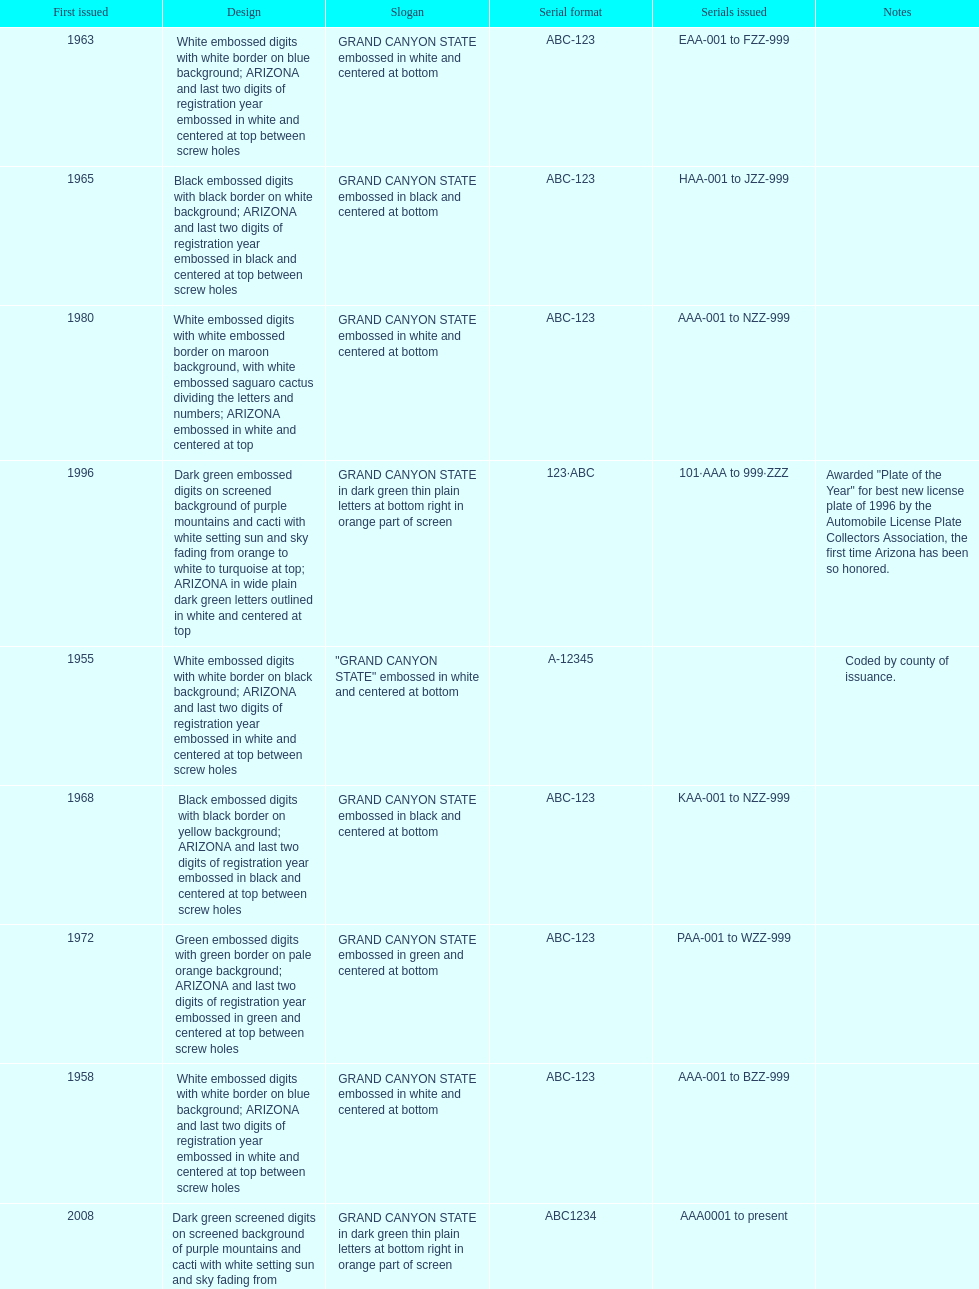Could you help me parse every detail presented in this table? {'header': ['First issued', 'Design', 'Slogan', 'Serial format', 'Serials issued', 'Notes'], 'rows': [['1963', 'White embossed digits with white border on blue background; ARIZONA and last two digits of registration year embossed in white and centered at top between screw holes', 'GRAND CANYON STATE embossed in white and centered at bottom', 'ABC-123', 'EAA-001 to FZZ-999', ''], ['1965', 'Black embossed digits with black border on white background; ARIZONA and last two digits of registration year embossed in black and centered at top between screw holes', 'GRAND CANYON STATE embossed in black and centered at bottom', 'ABC-123', 'HAA-001 to JZZ-999', ''], ['1980', 'White embossed digits with white embossed border on maroon background, with white embossed saguaro cactus dividing the letters and numbers; ARIZONA embossed in white and centered at top', 'GRAND CANYON STATE embossed in white and centered at bottom', 'ABC-123', 'AAA-001 to NZZ-999', ''], ['1996', 'Dark green embossed digits on screened background of purple mountains and cacti with white setting sun and sky fading from orange to white to turquoise at top; ARIZONA in wide plain dark green letters outlined in white and centered at top', 'GRAND CANYON STATE in dark green thin plain letters at bottom right in orange part of screen', '123·ABC', '101·AAA to 999·ZZZ', 'Awarded "Plate of the Year" for best new license plate of 1996 by the Automobile License Plate Collectors Association, the first time Arizona has been so honored.'], ['1955', 'White embossed digits with white border on black background; ARIZONA and last two digits of registration year embossed in white and centered at top between screw holes', '"GRAND CANYON STATE" embossed in white and centered at bottom', 'A-12345', '', 'Coded by county of issuance.'], ['1968', 'Black embossed digits with black border on yellow background; ARIZONA and last two digits of registration year embossed in black and centered at top between screw holes', 'GRAND CANYON STATE embossed in black and centered at bottom', 'ABC-123', 'KAA-001 to NZZ-999', ''], ['1972', 'Green embossed digits with green border on pale orange background; ARIZONA and last two digits of registration year embossed in green and centered at top between screw holes', 'GRAND CANYON STATE embossed in green and centered at bottom', 'ABC-123', 'PAA-001 to WZZ-999', ''], ['1958', 'White embossed digits with white border on blue background; ARIZONA and last two digits of registration year embossed in white and centered at top between screw holes', 'GRAND CANYON STATE embossed in white and centered at bottom', 'ABC-123', 'AAA-001 to BZZ-999', ''], ['2008', 'Dark green screened digits on screened background of purple mountains and cacti with white setting sun and sky fading from orange to white to turquoise at top; ARIZONA in wide plain dark green letters outlined in white and centered at top; security stripe through center of plate', 'GRAND CANYON STATE in dark green thin plain letters at bottom right in orange part of screen', 'ABC1234', 'AAA0001 to present', ''], ['1960', 'Blue embossed digits with blue border on white background; ARIZONA and last two digits of registration year embossed in blue and centered at top between screw holes', 'GRAND CANYON STATE embossed in blue and centered at bottom', 'ABC-123', 'CAA-001 to DZZ-999', '']]} Which year showcased the license plate with the minimal characters? 1955. 